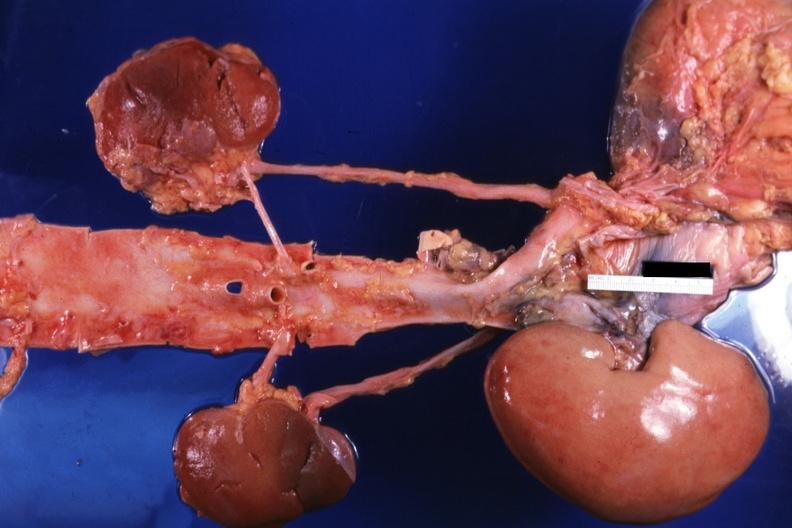s the transplant placed relative to other structures?
Answer the question using a single word or phrase. Yes 